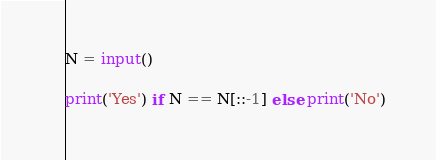Convert code to text. <code><loc_0><loc_0><loc_500><loc_500><_Python_>N = input()

print('Yes') if N == N[::-1] else print('No')</code> 